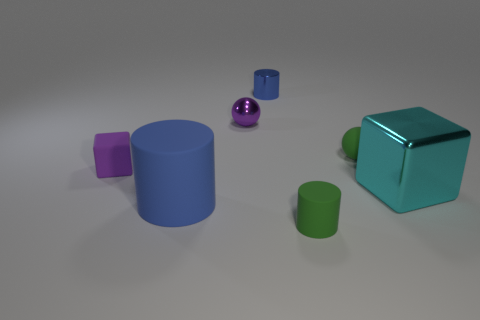What is the material of the small object that is the same color as the tiny rubber block?
Offer a very short reply. Metal. There is a block that is in front of the small rubber thing left of the big cylinder; what is its color?
Offer a very short reply. Cyan. How many purple objects are tiny metal objects or tiny rubber cubes?
Provide a succinct answer. 2. What color is the cylinder that is both in front of the metal cylinder and to the right of the small metal ball?
Keep it short and to the point. Green. How many small objects are yellow rubber balls or cyan metal objects?
Your response must be concise. 0. The other blue thing that is the same shape as the large blue object is what size?
Offer a very short reply. Small. What shape is the small blue metallic object?
Give a very brief answer. Cylinder. Does the green cylinder have the same material as the cube that is on the right side of the tiny metal ball?
Ensure brevity in your answer.  No. How many metallic things are either big cyan objects or green spheres?
Offer a very short reply. 1. There is a matte cylinder that is to the left of the tiny blue thing; how big is it?
Keep it short and to the point. Large. 